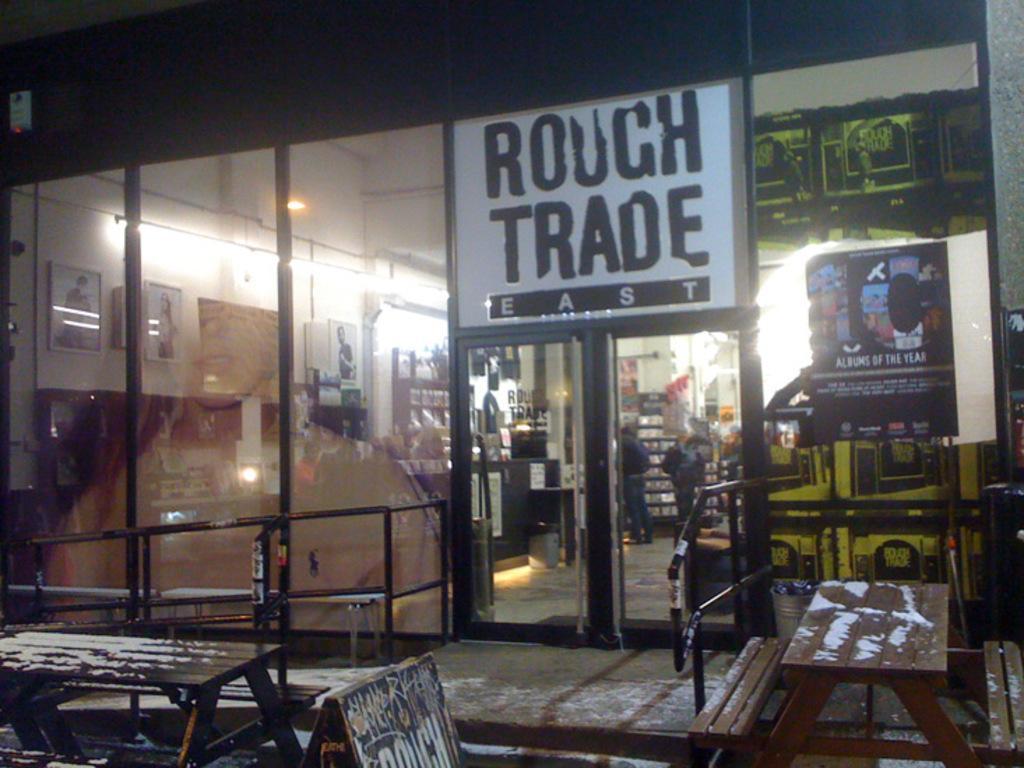Describe this image in one or two sentences. In this image in the center there is a building and glass doors, through the doors i can see some objects and some photo frames, wall, light and some other objects. At the bottom there are benches and some poles and railing. In the center there is one board, on the board there is text. 